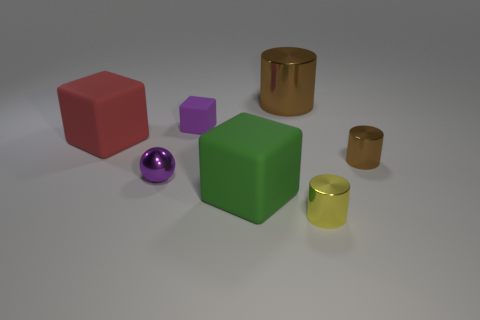Add 2 gray matte balls. How many objects exist? 9 Subtract all cylinders. How many objects are left? 4 Add 6 tiny brown metal balls. How many tiny brown metal balls exist? 6 Subtract 1 yellow cylinders. How many objects are left? 6 Subtract all big brown matte blocks. Subtract all small spheres. How many objects are left? 6 Add 4 tiny purple shiny spheres. How many tiny purple shiny spheres are left? 5 